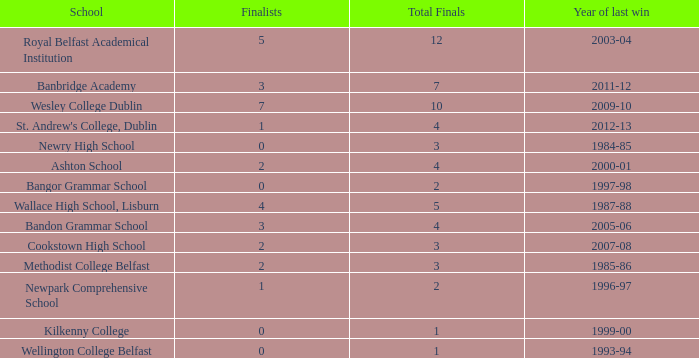Which school had its most recent victory in the 1985-86 school year? Methodist College Belfast. 